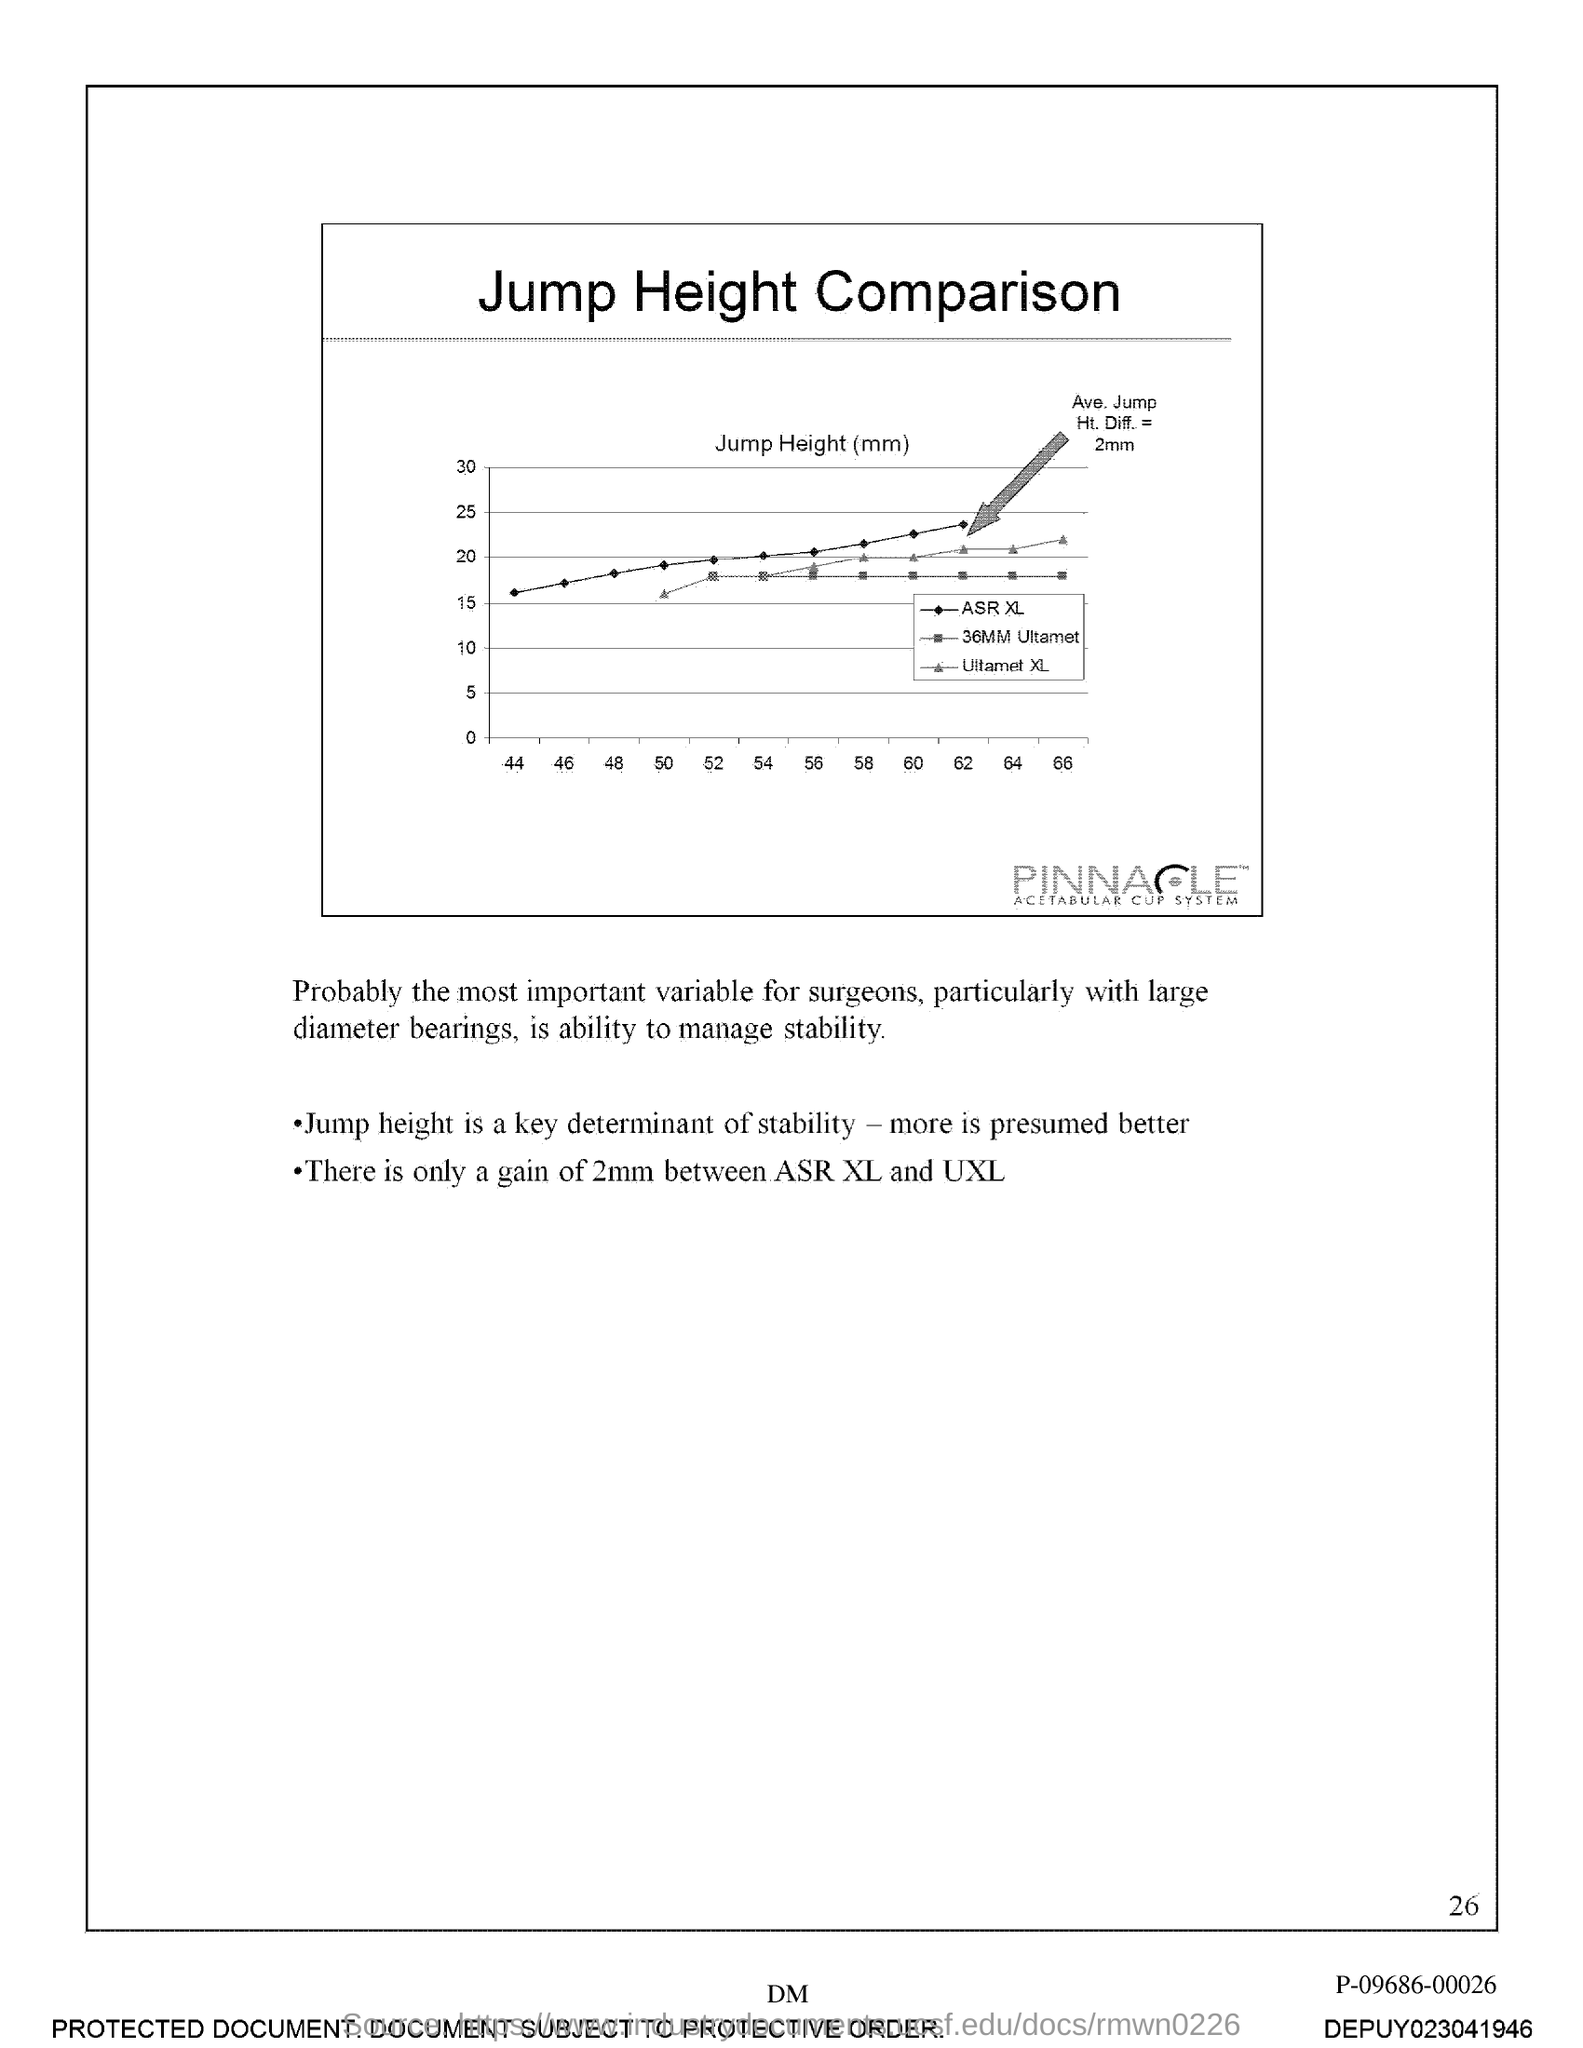What is the title of the document?
Your response must be concise. Jump height comparison. 